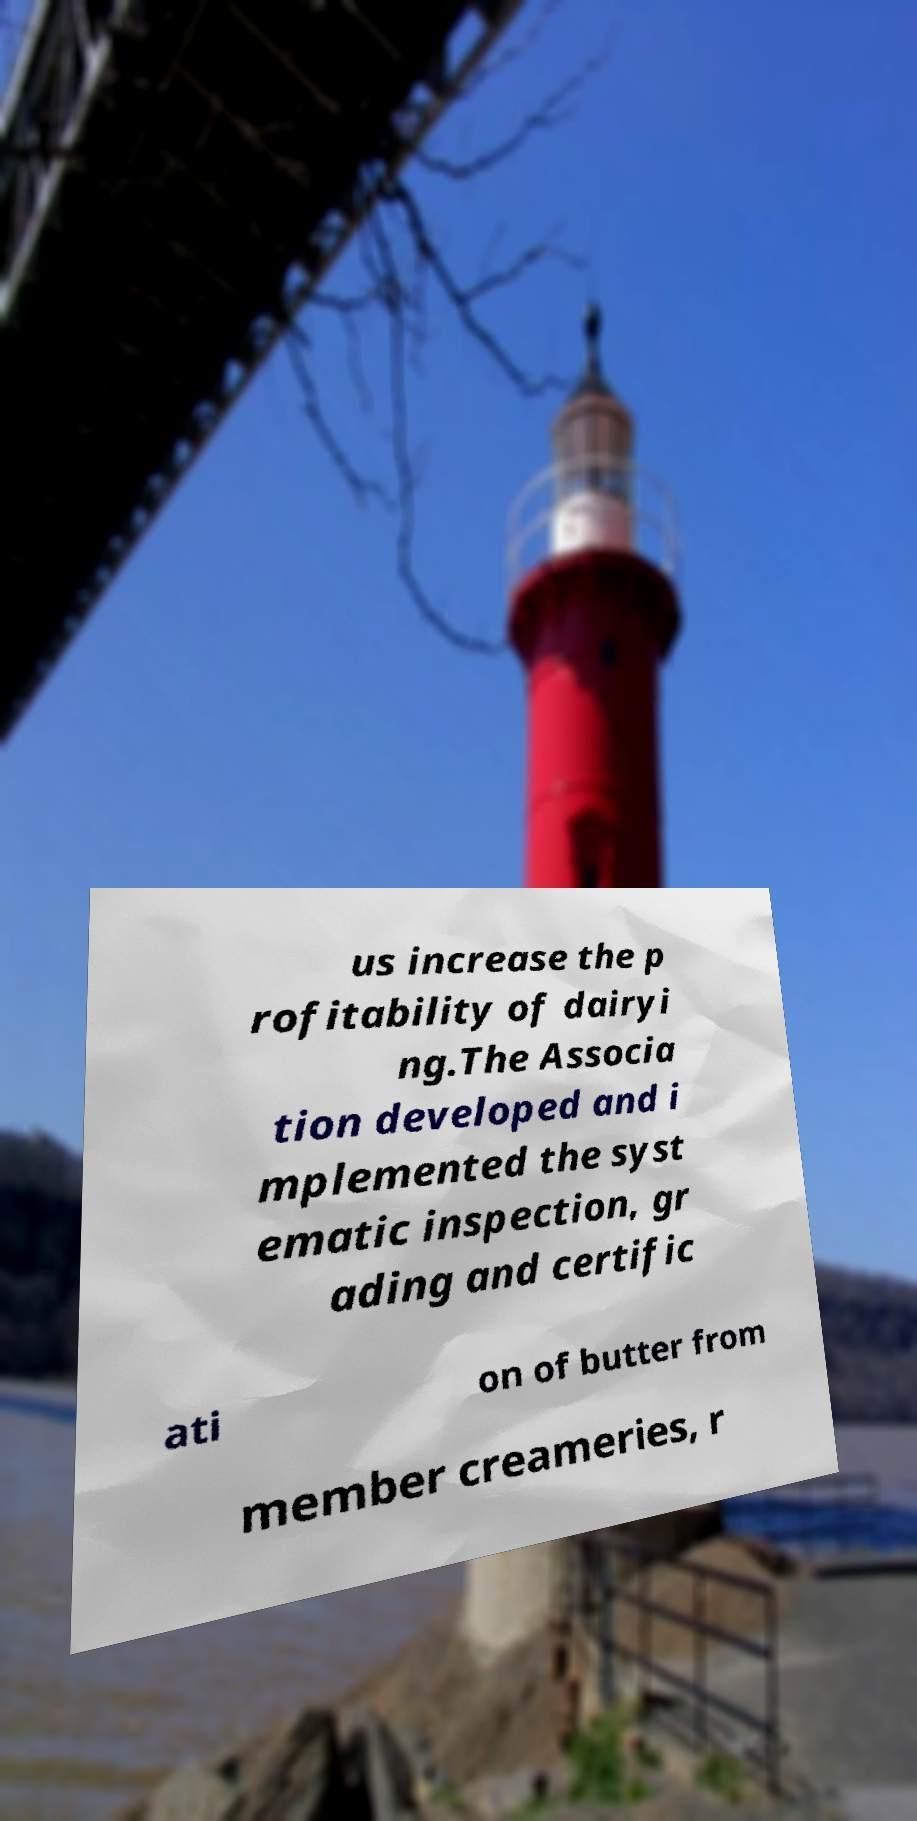Can you accurately transcribe the text from the provided image for me? us increase the p rofitability of dairyi ng.The Associa tion developed and i mplemented the syst ematic inspection, gr ading and certific ati on of butter from member creameries, r 